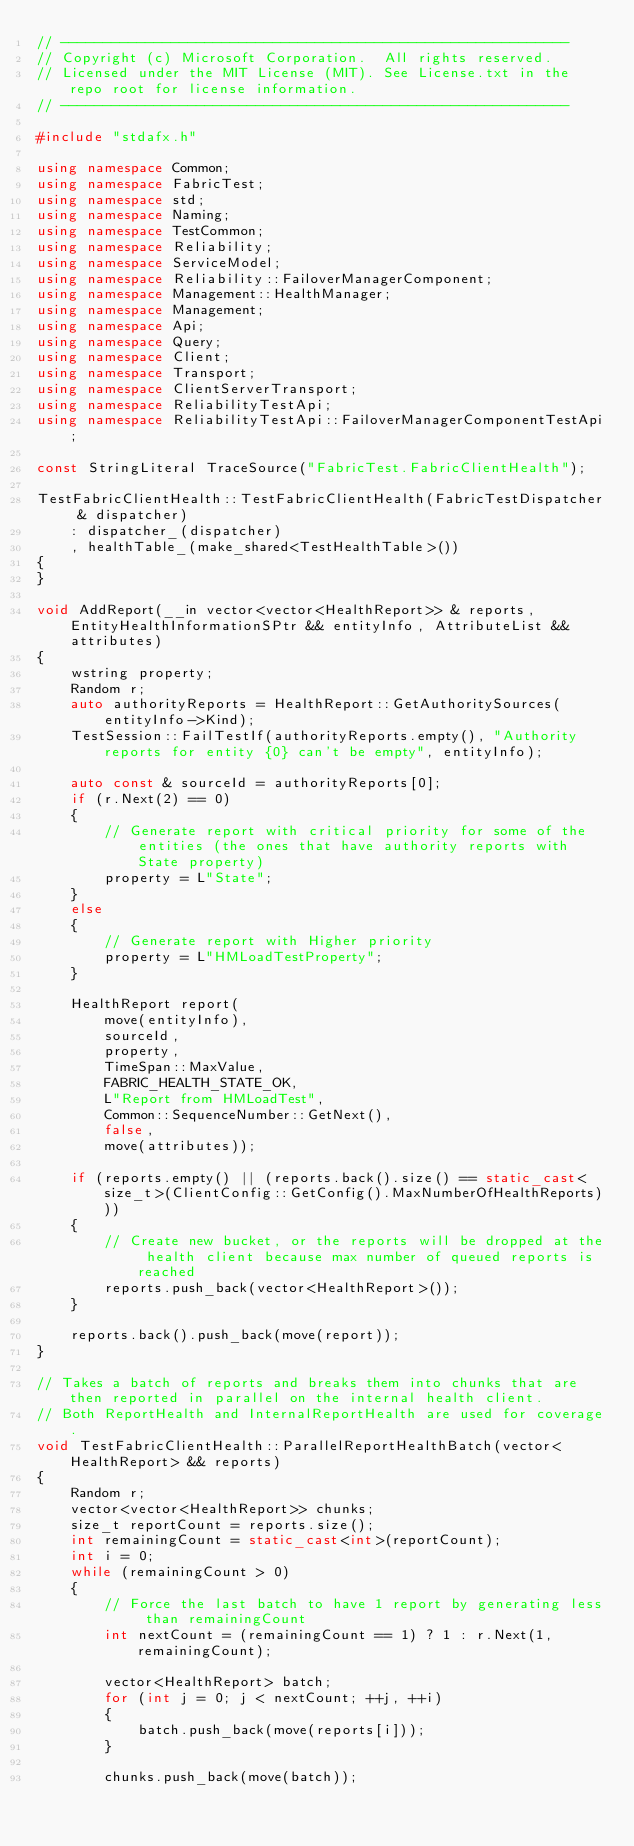<code> <loc_0><loc_0><loc_500><loc_500><_C++_>// ------------------------------------------------------------
// Copyright (c) Microsoft Corporation.  All rights reserved.
// Licensed under the MIT License (MIT). See License.txt in the repo root for license information.
// ------------------------------------------------------------

#include "stdafx.h"

using namespace Common;
using namespace FabricTest;
using namespace std;
using namespace Naming;
using namespace TestCommon;
using namespace Reliability;
using namespace ServiceModel;
using namespace Reliability::FailoverManagerComponent;
using namespace Management::HealthManager;
using namespace Management;
using namespace Api;
using namespace Query;
using namespace Client;
using namespace Transport;
using namespace ClientServerTransport;
using namespace ReliabilityTestApi;
using namespace ReliabilityTestApi::FailoverManagerComponentTestApi;

const StringLiteral TraceSource("FabricTest.FabricClientHealth");

TestFabricClientHealth::TestFabricClientHealth(FabricTestDispatcher & dispatcher)
    : dispatcher_(dispatcher)
    , healthTable_(make_shared<TestHealthTable>())
{
}

void AddReport(__in vector<vector<HealthReport>> & reports, EntityHealthInformationSPtr && entityInfo, AttributeList && attributes)
{
    wstring property;
    Random r;
    auto authorityReports = HealthReport::GetAuthoritySources(entityInfo->Kind);
    TestSession::FailTestIf(authorityReports.empty(), "Authority reports for entity {0} can't be empty", entityInfo);

    auto const & sourceId = authorityReports[0];
    if (r.Next(2) == 0)
    {
        // Generate report with critical priority for some of the entities (the ones that have authority reports with State property)
        property = L"State";
    }
    else
    {
        // Generate report with Higher priority
        property = L"HMLoadTestProperty";
    }

    HealthReport report(
        move(entityInfo),
        sourceId,
        property,
        TimeSpan::MaxValue,
        FABRIC_HEALTH_STATE_OK,
        L"Report from HMLoadTest",
        Common::SequenceNumber::GetNext(),
        false,
        move(attributes));

    if (reports.empty() || (reports.back().size() == static_cast<size_t>(ClientConfig::GetConfig().MaxNumberOfHealthReports)))
    {
        // Create new bucket, or the reports will be dropped at the health client because max number of queued reports is reached
        reports.push_back(vector<HealthReport>());
    }

    reports.back().push_back(move(report));
}

// Takes a batch of reports and breaks them into chunks that are then reported in parallel on the internal health client.
// Both ReportHealth and InternalReportHealth are used for coverage.
void TestFabricClientHealth::ParallelReportHealthBatch(vector<HealthReport> && reports)
{
    Random r;
    vector<vector<HealthReport>> chunks;
    size_t reportCount = reports.size();
    int remainingCount = static_cast<int>(reportCount);
    int i = 0;
    while (remainingCount > 0)
    {
        // Force the last batch to have 1 report by generating less than remainingCount
        int nextCount = (remainingCount == 1) ? 1 : r.Next(1, remainingCount);

        vector<HealthReport> batch;
        for (int j = 0; j < nextCount; ++j, ++i)
        {
            batch.push_back(move(reports[i]));
        }
    
        chunks.push_back(move(batch));</code> 